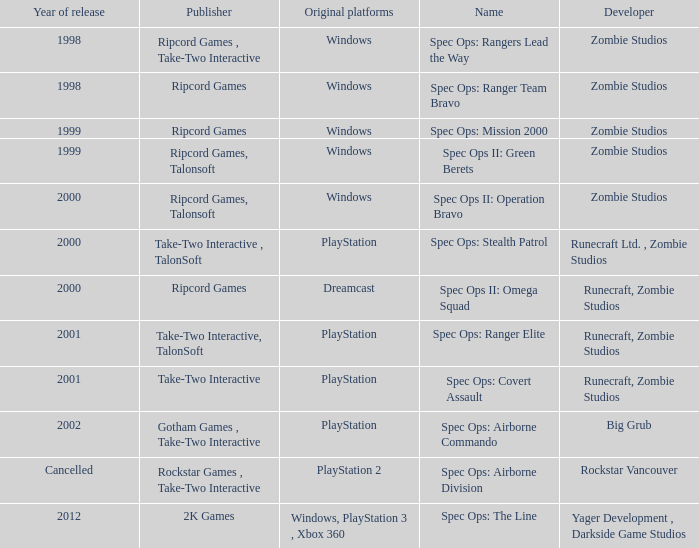Which publisher is responsible for spec ops: stealth patrol? Take-Two Interactive , TalonSoft. 